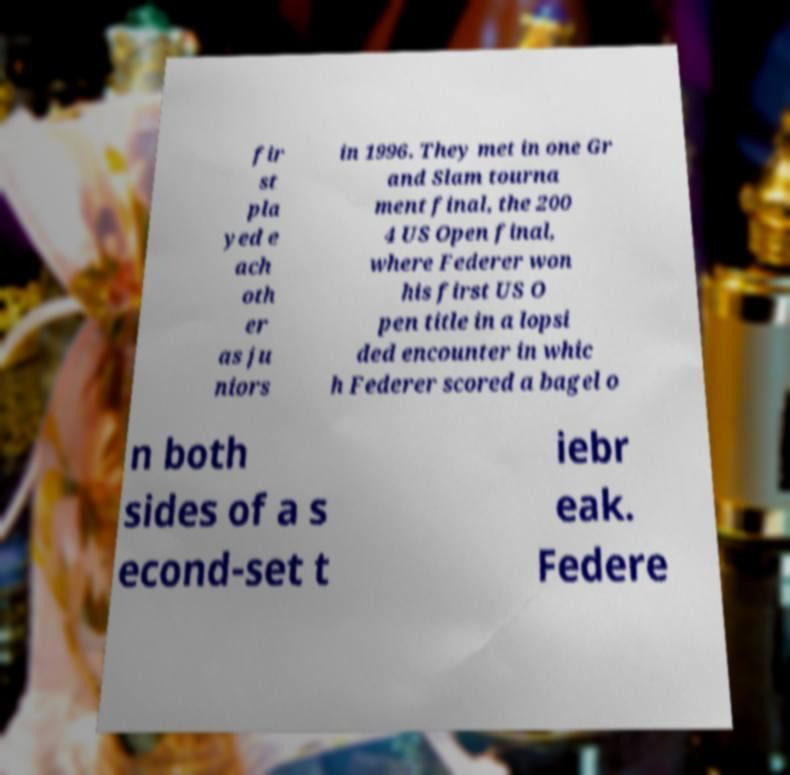Could you assist in decoding the text presented in this image and type it out clearly? fir st pla yed e ach oth er as ju niors in 1996. They met in one Gr and Slam tourna ment final, the 200 4 US Open final, where Federer won his first US O pen title in a lopsi ded encounter in whic h Federer scored a bagel o n both sides of a s econd-set t iebr eak. Federe 